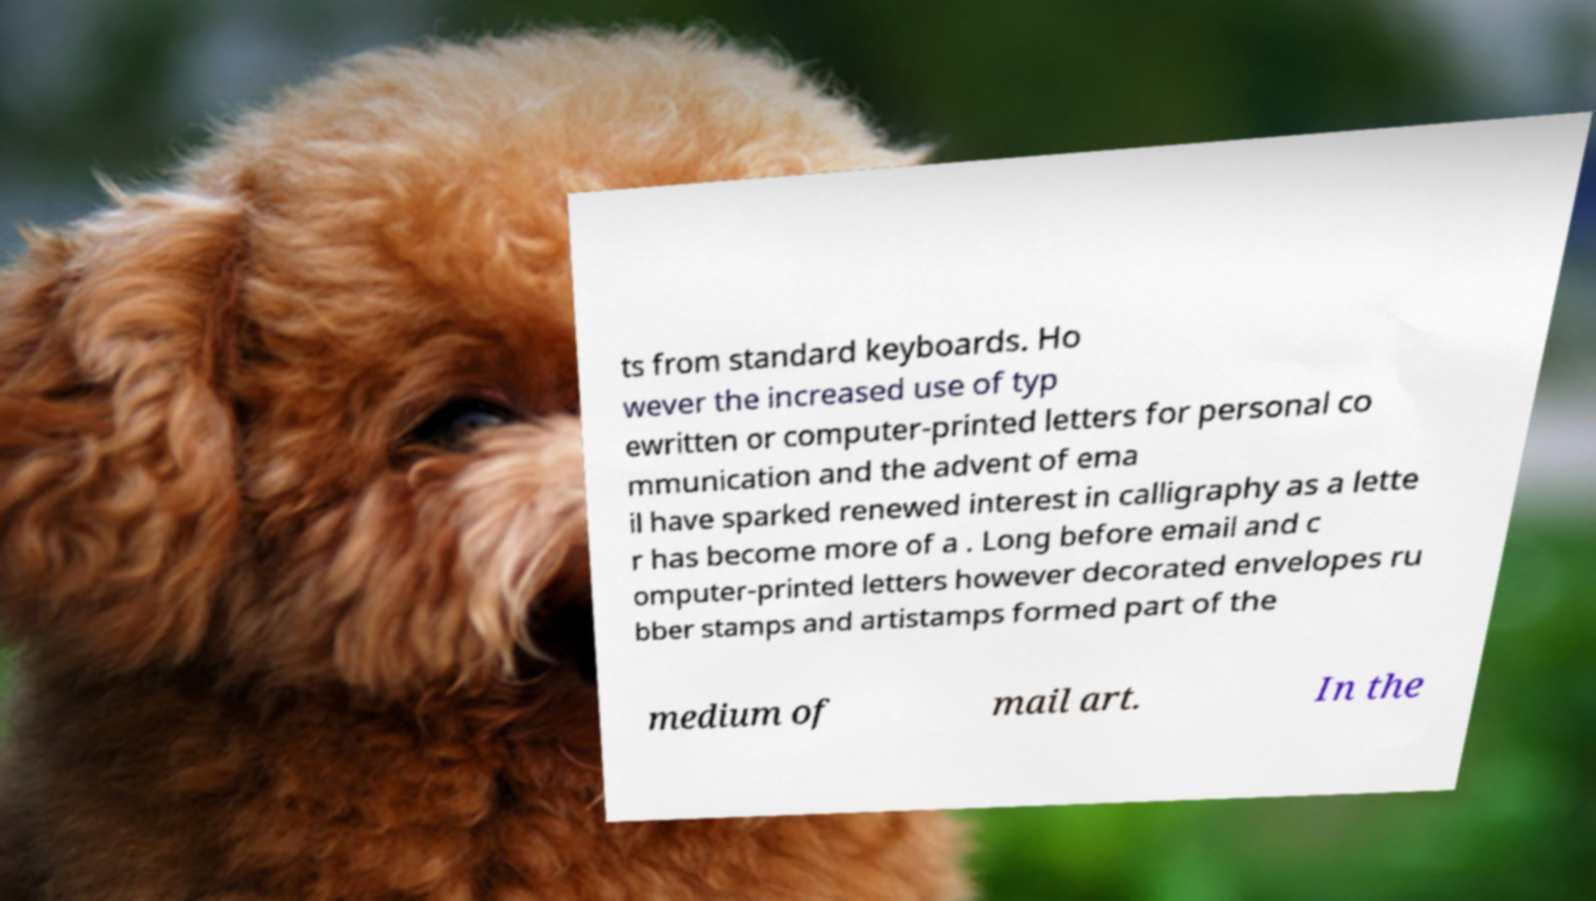Could you assist in decoding the text presented in this image and type it out clearly? ts from standard keyboards. Ho wever the increased use of typ ewritten or computer-printed letters for personal co mmunication and the advent of ema il have sparked renewed interest in calligraphy as a lette r has become more of a . Long before email and c omputer-printed letters however decorated envelopes ru bber stamps and artistamps formed part of the medium of mail art. In the 